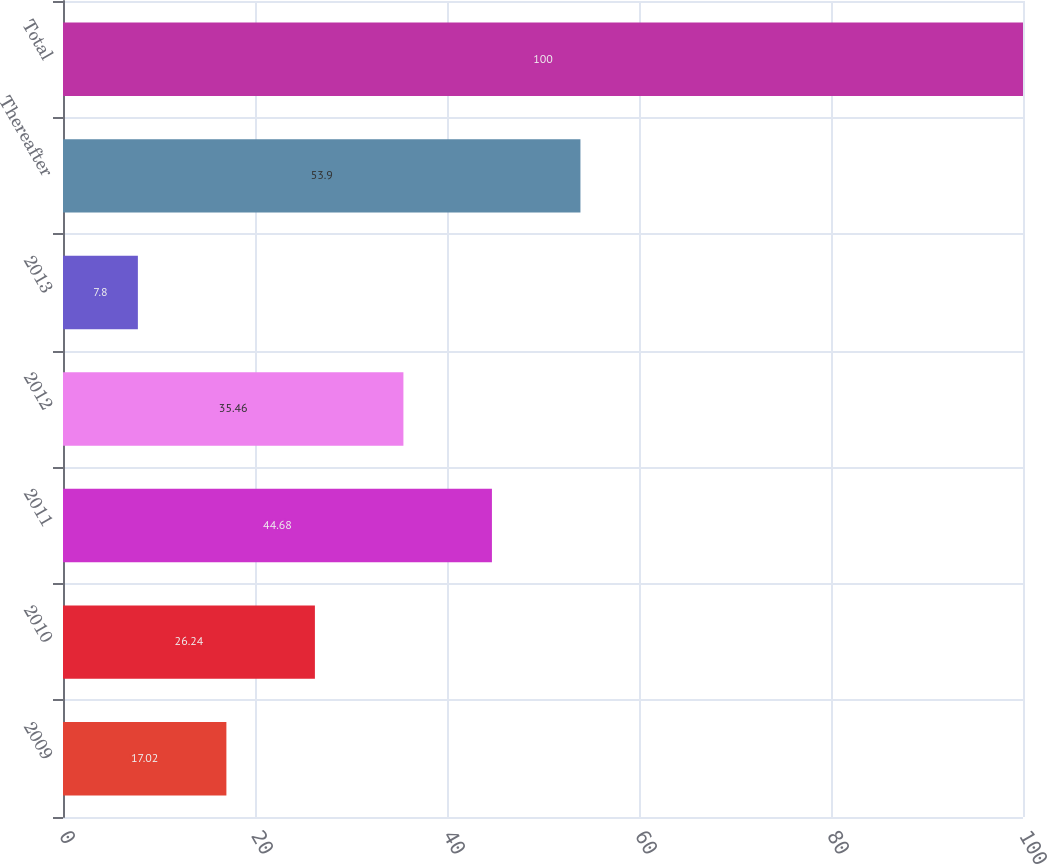<chart> <loc_0><loc_0><loc_500><loc_500><bar_chart><fcel>2009<fcel>2010<fcel>2011<fcel>2012<fcel>2013<fcel>Thereafter<fcel>Total<nl><fcel>17.02<fcel>26.24<fcel>44.68<fcel>35.46<fcel>7.8<fcel>53.9<fcel>100<nl></chart> 